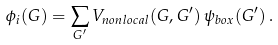Convert formula to latex. <formula><loc_0><loc_0><loc_500><loc_500>\phi _ { i } ( { G } ) = \sum _ { { G } ^ { \prime } } V _ { n o n l o c a l } ( { G } , { G } ^ { \prime } ) \, \psi _ { b o x } ( { G } ^ { \prime } ) \, .</formula> 